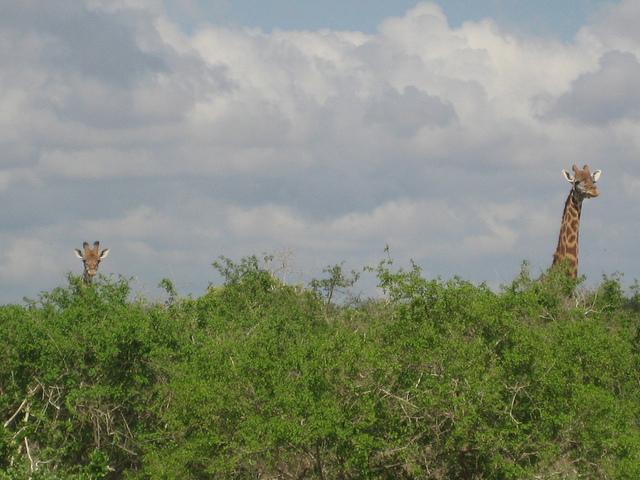How many animals are in this photo?
Give a very brief answer. 2. 